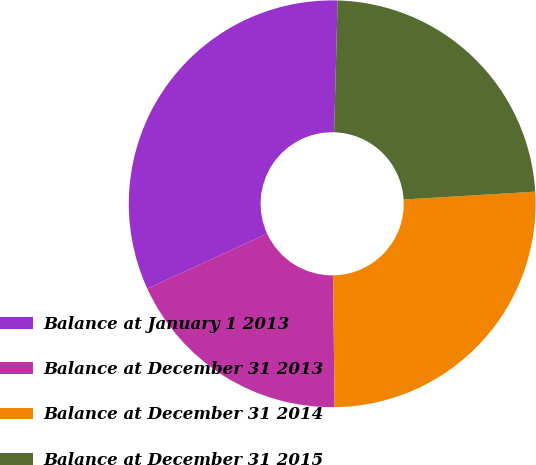Convert chart to OTSL. <chart><loc_0><loc_0><loc_500><loc_500><pie_chart><fcel>Balance at January 1 2013<fcel>Balance at December 31 2013<fcel>Balance at December 31 2014<fcel>Balance at December 31 2015<nl><fcel>32.28%<fcel>18.34%<fcel>25.76%<fcel>23.62%<nl></chart> 